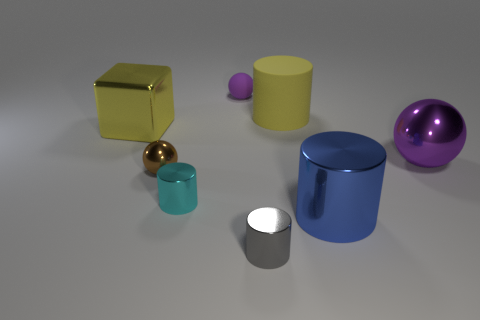Subtract all gray cylinders. How many cylinders are left? 3 Subtract all brown cylinders. Subtract all blue spheres. How many cylinders are left? 4 Add 1 big brown rubber things. How many objects exist? 9 Subtract all cubes. How many objects are left? 7 Subtract all big purple shiny things. Subtract all tiny shiny cylinders. How many objects are left? 5 Add 6 cyan metallic things. How many cyan metallic things are left? 7 Add 5 large cyan rubber things. How many large cyan rubber things exist? 5 Subtract 0 green cylinders. How many objects are left? 8 